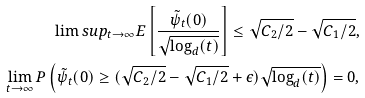<formula> <loc_0><loc_0><loc_500><loc_500>\lim s u p _ { t \to \infty } E \left [ \frac { \tilde { \psi } _ { t } ( 0 ) } { \sqrt { \log _ { d } ( t ) } } \right ] \leq \sqrt { C _ { 2 } / 2 } - \sqrt { C _ { 1 } / 2 } , \\ \lim _ { t \to \infty } P \left ( \tilde { \psi } _ { t } ( 0 ) \geq ( \sqrt { C _ { 2 } / 2 } - \sqrt { C _ { 1 } / 2 } + \epsilon ) \sqrt { \log _ { d } ( t ) } \right ) = 0 ,</formula> 